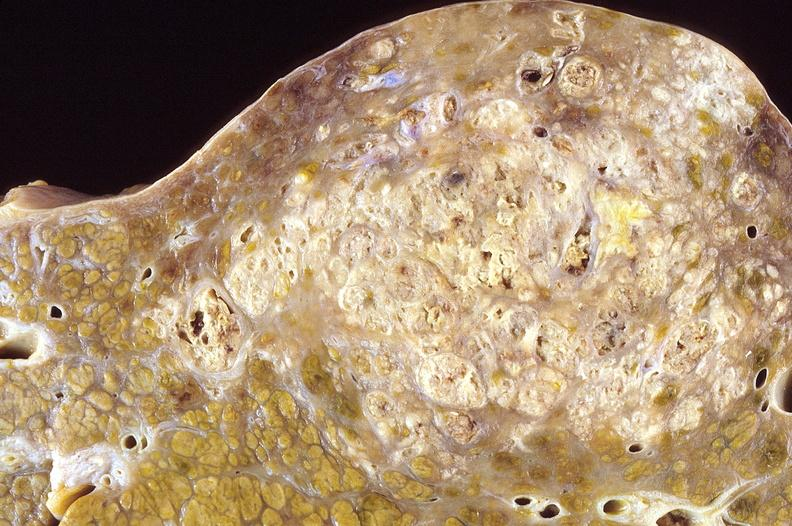what does this image show?
Answer the question using a single word or phrase. Hepatocellular carcinoma 